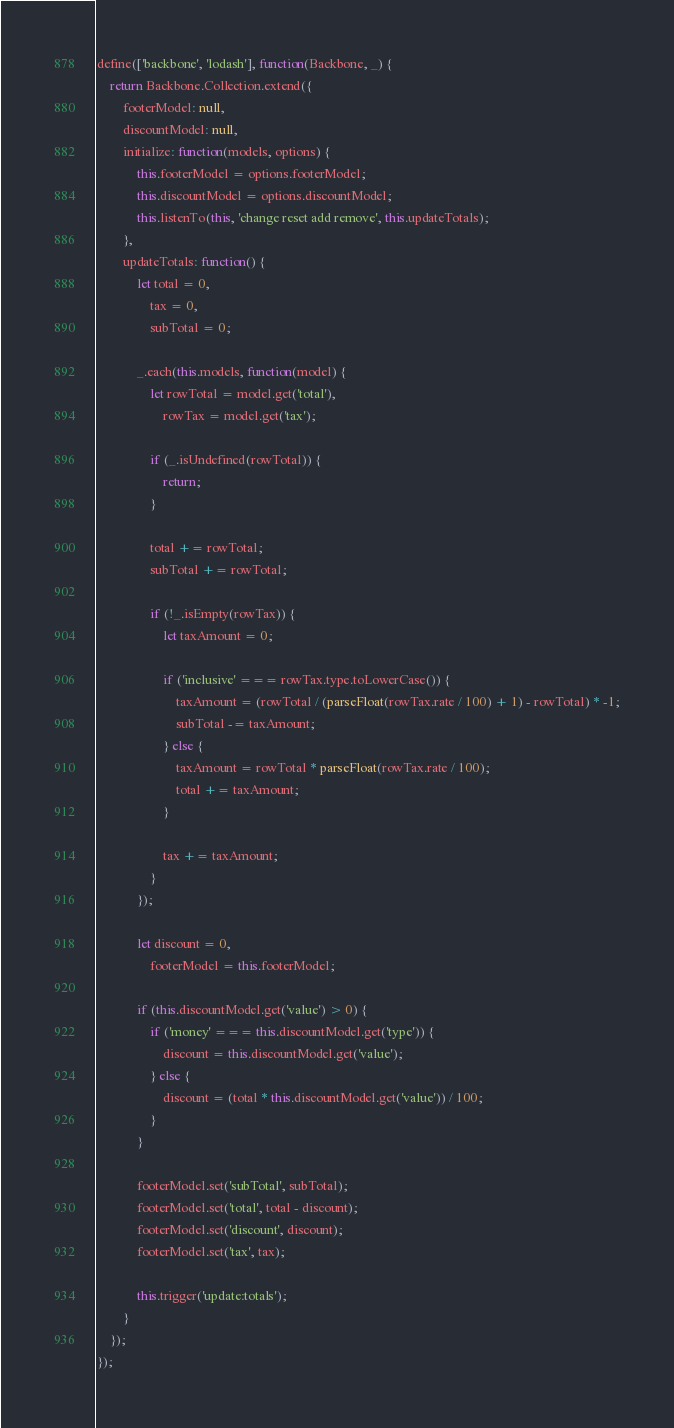<code> <loc_0><loc_0><loc_500><loc_500><_JavaScript_>define(['backbone', 'lodash'], function(Backbone, _) {
    return Backbone.Collection.extend({
        footerModel: null,
        discountModel: null,
        initialize: function(models, options) {
            this.footerModel = options.footerModel;
            this.discountModel = options.discountModel;
            this.listenTo(this, 'change reset add remove', this.updateTotals);
        },
        updateTotals: function() {
            let total = 0,
                tax = 0,
                subTotal = 0;

            _.each(this.models, function(model) {
                let rowTotal = model.get('total'),
                    rowTax = model.get('tax');

                if (_.isUndefined(rowTotal)) {
                    return;
                }

                total += rowTotal;
                subTotal += rowTotal;

                if (!_.isEmpty(rowTax)) {
                    let taxAmount = 0;

                    if ('inclusive' === rowTax.type.toLowerCase()) {
                        taxAmount = (rowTotal / (parseFloat(rowTax.rate / 100) + 1) - rowTotal) * -1;
                        subTotal -= taxAmount;
                    } else {
                        taxAmount = rowTotal * parseFloat(rowTax.rate / 100);
                        total += taxAmount;
                    }

                    tax += taxAmount;
                }
            });

            let discount = 0,
                footerModel = this.footerModel;

            if (this.discountModel.get('value') > 0) {
                if ('money' === this.discountModel.get('type')) {
                    discount = this.discountModel.get('value');
                } else {
                    discount = (total * this.discountModel.get('value')) / 100;
                }
            }

            footerModel.set('subTotal', subTotal);
            footerModel.set('total', total - discount);
            footerModel.set('discount', discount);
            footerModel.set('tax', tax);

            this.trigger('update:totals');
        }
    });
});</code> 